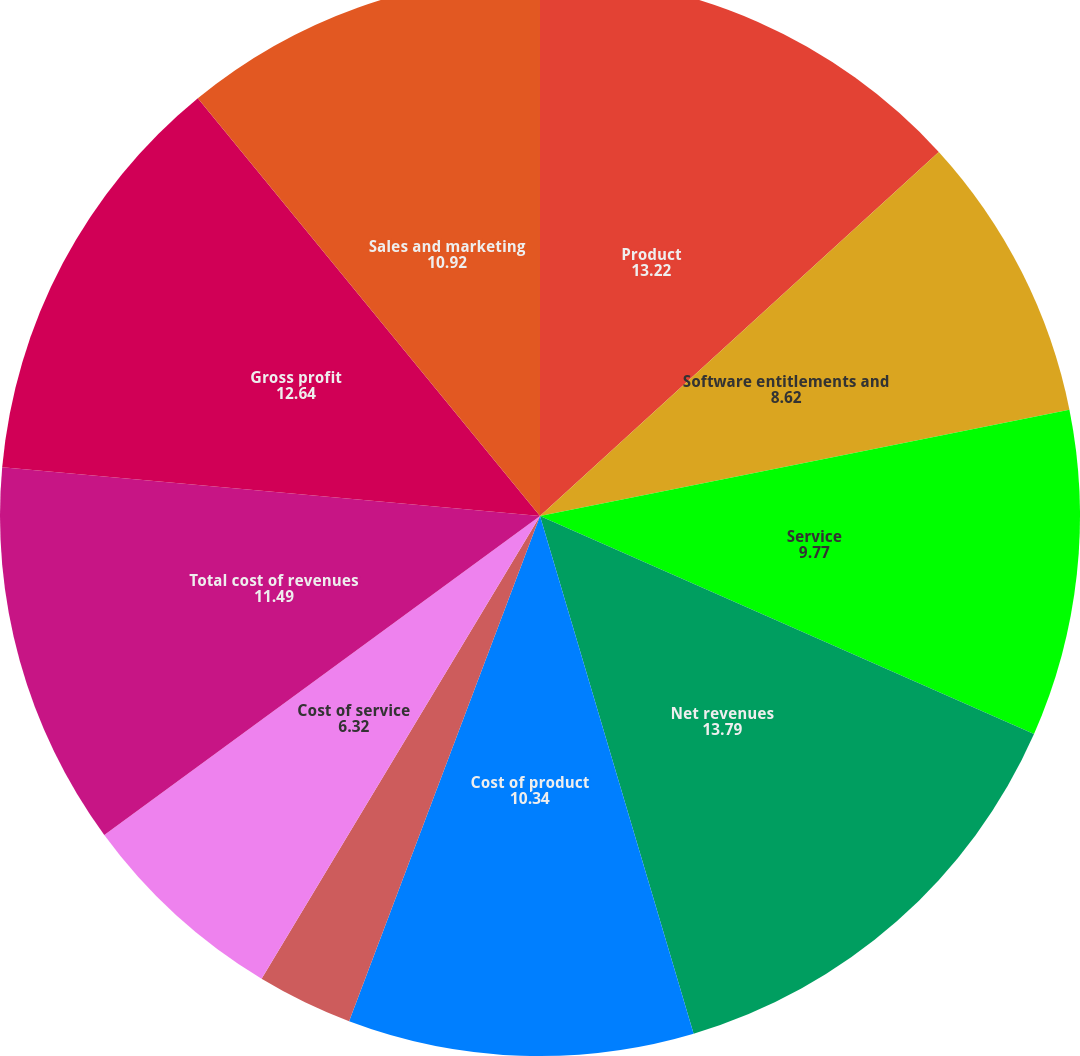<chart> <loc_0><loc_0><loc_500><loc_500><pie_chart><fcel>Product<fcel>Software entitlements and<fcel>Service<fcel>Net revenues<fcel>Cost of product<fcel>Cost of software entitlements<fcel>Cost of service<fcel>Total cost of revenues<fcel>Gross profit<fcel>Sales and marketing<nl><fcel>13.22%<fcel>8.62%<fcel>9.77%<fcel>13.79%<fcel>10.34%<fcel>2.87%<fcel>6.32%<fcel>11.49%<fcel>12.64%<fcel>10.92%<nl></chart> 